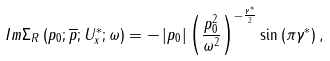Convert formula to latex. <formula><loc_0><loc_0><loc_500><loc_500>I m \Sigma _ { R } \left ( p _ { 0 } ; \overline { p } ; U _ { x } ^ { * } ; \omega \right ) = - \left | p _ { 0 } \right | \left ( \frac { p ^ { 2 } _ { 0 } } { \omega ^ { 2 } } \right ) ^ { - \frac { \gamma ^ { * } } { 2 } } \sin \left ( \pi \gamma ^ { * } \right ) ,</formula> 